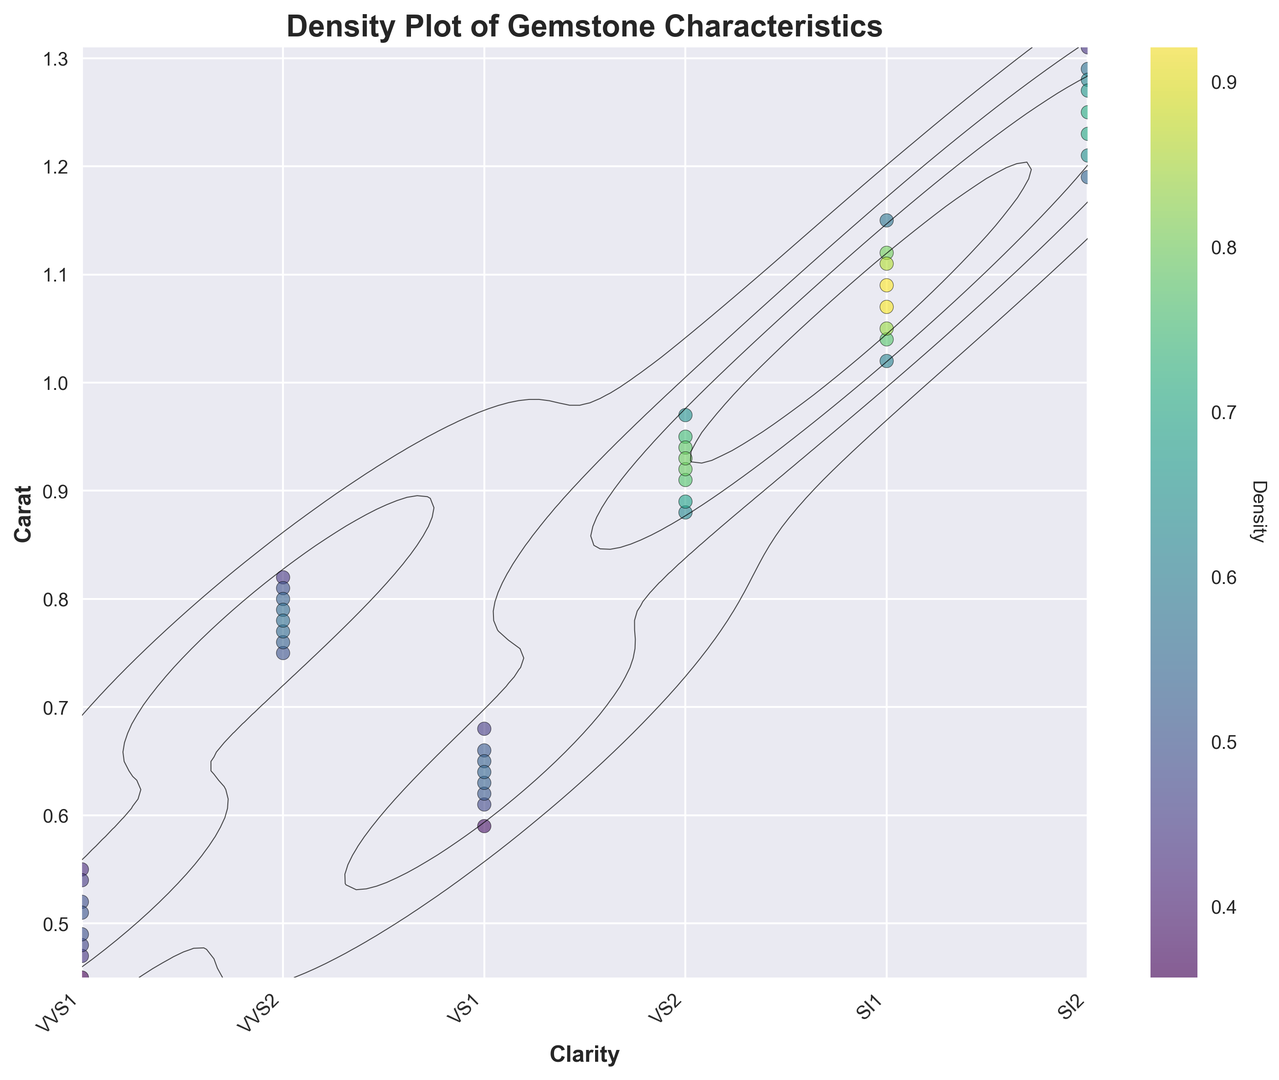What is the overall trend observed between clarity and carat? By looking at the contour density plot, one can observe that as the clarity level decreases (moving left to right on the x-axis), the carat generally increases (moving up on the y-axis). This indicates a trend where stones with lower clarity levels tend to have higher carat values.
Answer: Lower clarity stones have higher carat Which clarity level has the highest density of carat values? Observe the color intensity and density of the contour lines in the plot. The clarity level with the highest density will have the darkest colors and the most tightly packed contour lines around specific carat values.
Answer: SI2 What is the carat value range for VVS1 with the highest density? By referring to the figure, identify the range of carat values where the contour lines for VVS1 are most densely packed.
Answer: Approx. 0.45-0.55 Is the density distribution for VS2 more spread out or concentrated compared to SI1? Check the spread of the density colors and the contour lines. If VS2 has more dispersed colors and contour lines compared to SI1, it is more spread out; otherwise, it is more concentrated.
Answer: VS2 is more spread out Among VVS2 and VS2, which clarity level exhibits a wider range of carat values with higher density? Look for the clarity levels where the contour lines extend over a wider range along the carat axis with the highest density levels.
Answer: VS2 Comparing VVS1 and SI2, which clarity level shows a higher density for lower carat values (less than 1 carat)? Examine the density colors and contour line distribution for carat values less than 1. Determine where the density is higher for VVS1 or SI2 within this range.
Answer: VVS1 Which clarity level has a more uniform distribution of carat values? Identify which clarity level has contour lines and color intensity distributed more evenly across the range of carat values.
Answer: VVS2 How does the density distribution for SI1 compare to SI2? Compare the density colors and contour lines between SI1 and SI2. Determine if one has higher density levels or if they are distributed differently.
Answer: SI2 shows a higher density Are there any clarity levels that show significantly low density for particular carat values? Look for regions within the density plot where the colors are very light or contour lines are sparse, indicating low density.
Answer: No significant low-density regions noted Are the contour lines for VVS1 smooth or do they show any irregular patterns? Observe the shape and distribution of the contour lines around VVS1. Determine if they form smooth, consistent curves or if there are any irregularities.
Answer: Smooth 